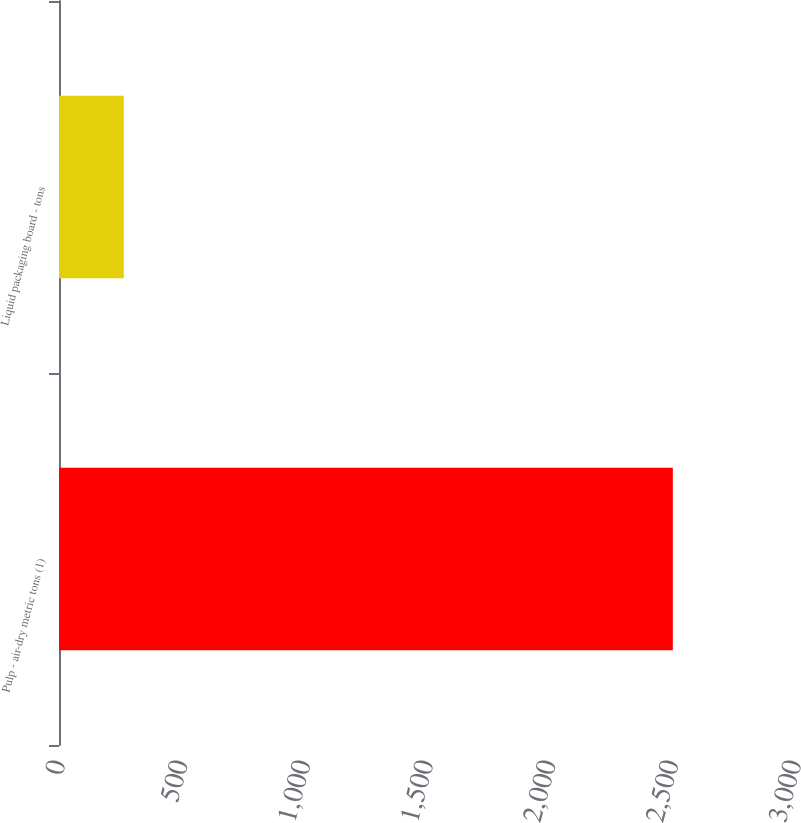<chart> <loc_0><loc_0><loc_500><loc_500><bar_chart><fcel>Pulp - air-dry metric tons (1)<fcel>Liquid packaging board - tons<nl><fcel>2502<fcel>264<nl></chart> 